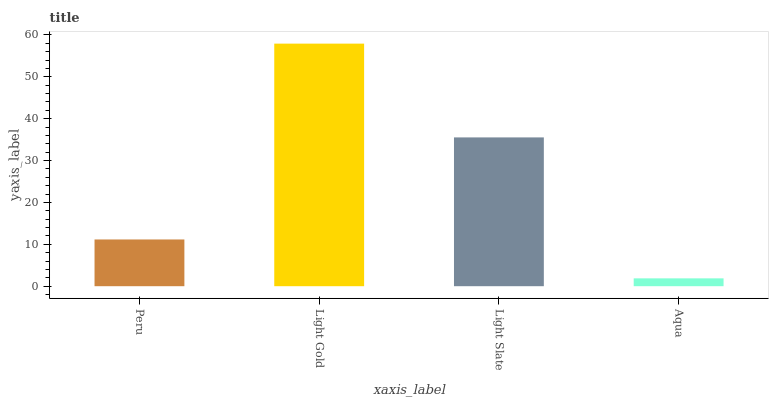Is Aqua the minimum?
Answer yes or no. Yes. Is Light Gold the maximum?
Answer yes or no. Yes. Is Light Slate the minimum?
Answer yes or no. No. Is Light Slate the maximum?
Answer yes or no. No. Is Light Gold greater than Light Slate?
Answer yes or no. Yes. Is Light Slate less than Light Gold?
Answer yes or no. Yes. Is Light Slate greater than Light Gold?
Answer yes or no. No. Is Light Gold less than Light Slate?
Answer yes or no. No. Is Light Slate the high median?
Answer yes or no. Yes. Is Peru the low median?
Answer yes or no. Yes. Is Aqua the high median?
Answer yes or no. No. Is Aqua the low median?
Answer yes or no. No. 